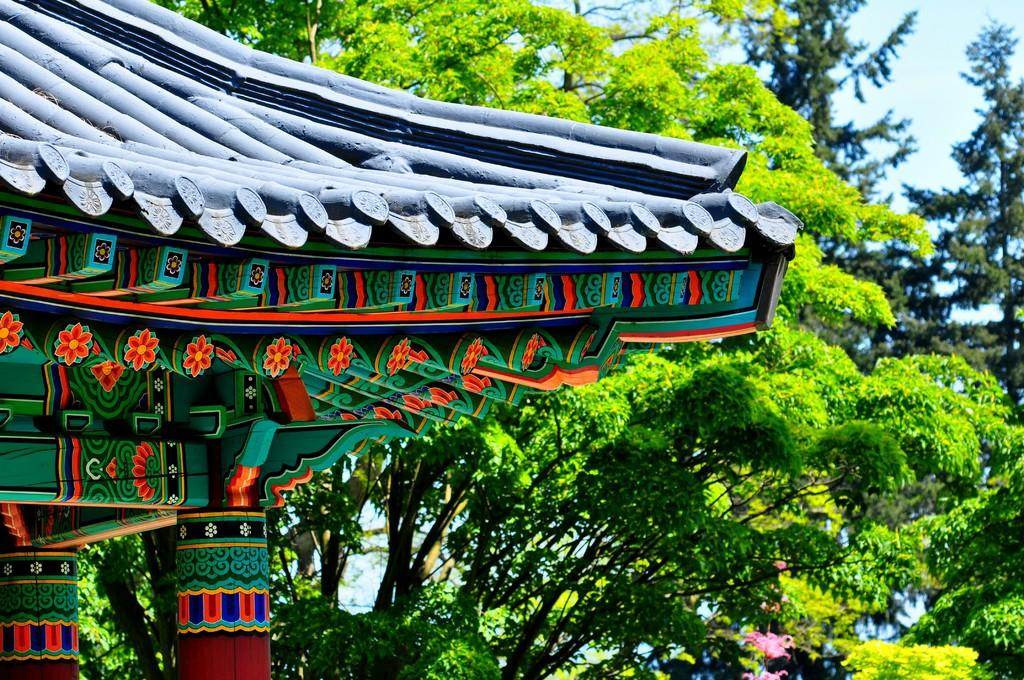What structure is located in the left corner of the image? There are pillars with a roof in the left corner of the image. What type of natural elements can be seen in the background of the image? There are trees in the background of the image. What is visible at the top of the image? The sky is visible at the top of the image. Where is the flock of birds located in the image? There is no flock of birds present in the image. What type of church can be seen in the image? There is no church present in the image. 